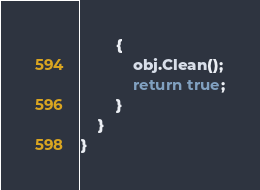Convert code to text. <code><loc_0><loc_0><loc_500><loc_500><_C#_>        {
            obj.Clean();
            return true;
        }
    }
}
</code> 